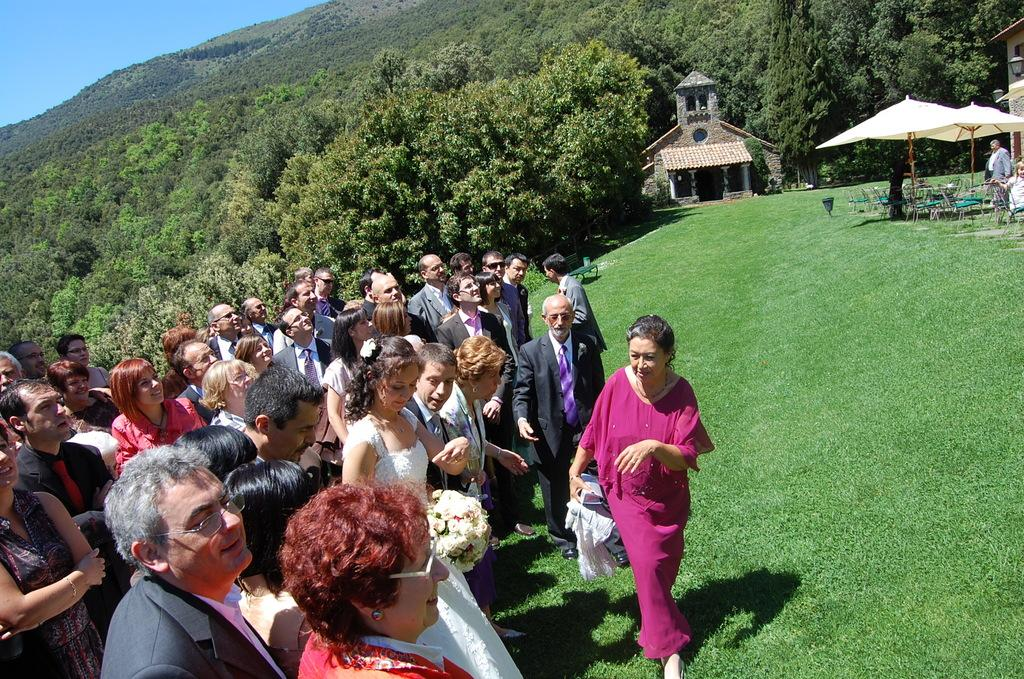What is the main subject of the image? The main subject of the image is a crowd standing on the ground. What can be seen in the background of the image? In the background, there are hills, trees, buildings, street lights, and parasols. Are there any objects visible in the background that people might sit on? Yes, chairs are visible in the background. What type of poison can be seen dripping from the parasols in the image? There is no poison present in the image; parasols are simply umbrellas used for shade. How many pins are visible on the chairs in the image? There are no pins visible on the chairs in the image. 